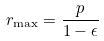<formula> <loc_0><loc_0><loc_500><loc_500>r _ { \max } = \frac { p } { 1 - \epsilon }</formula> 